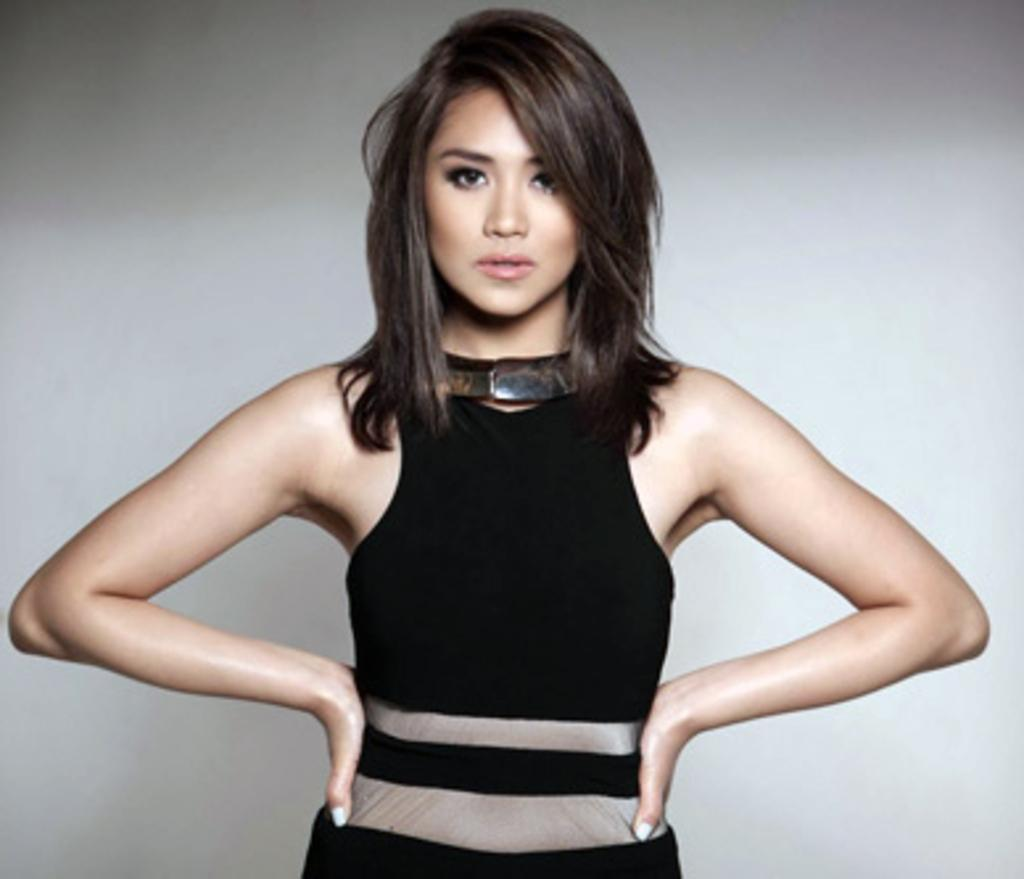Who is present in the image? There is a woman in the image. What is the woman doing in the image? The woman is standing. What is the woman wearing in the image? The woman is wearing a black dress. What can be seen in the background of the image? There is a well in the background of the image. What type of skirt is the woman wearing in the image? The woman is not wearing a skirt in the image; she is wearing a black dress. Can you tell me how many family members are present in the image? There is no indication of family members in the image; only the woman is present. 